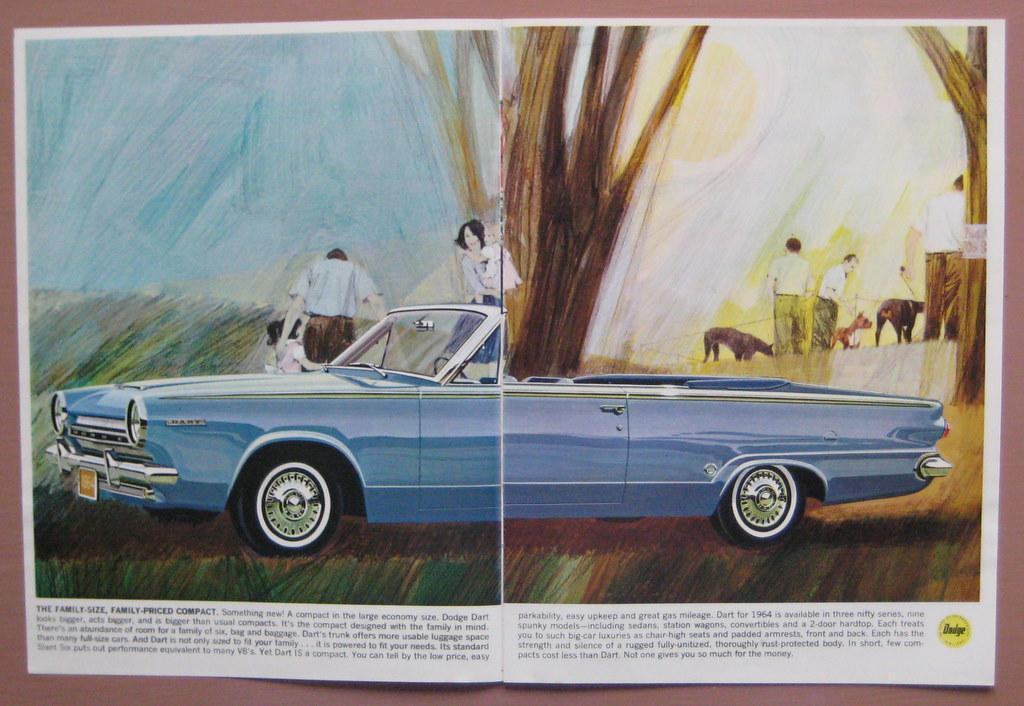What can be seen on the page? There are persons depicted on the page, and there is text on the page. Can you describe the persons depicted on the page? Unfortunately, the provided facts do not give any details about the persons depicted on the page. What is the purpose of the text on the page? The purpose of the text on the page cannot be determined from the provided facts. What type of blood is visible on the page? There is no blood visible on the page. What industry is depicted in the art on the page? There is no art or industry depicted on the page; it only contains persons and text. 